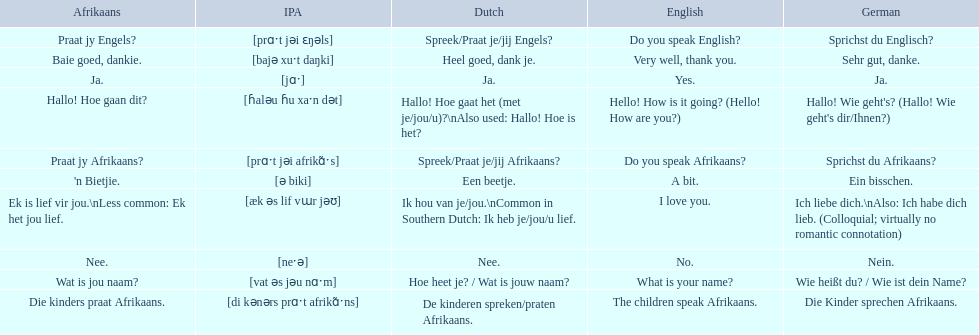How do you say hello! how is it going? in afrikaans? Hallo! Hoe gaan dit?. How do you say very well, thank you in afrikaans? Baie goed, dankie. How would you say do you speak afrikaans? in afrikaans? Praat jy Afrikaans?. 